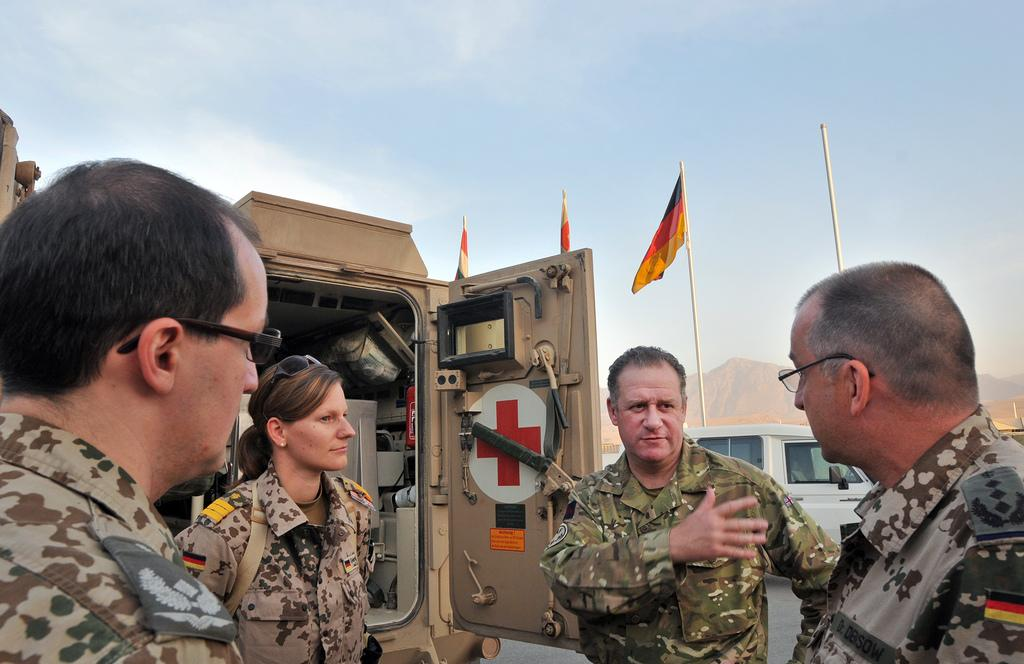How many military people are in the image? There are four military people in the image. What type of vehicle is present in the image? There is a hospital van with some equipment in the image. What can be seen in the sky in the image? The sky is visible in the image. What is the road condition in the image? There is a vehicle on the road in the image. What type of flags are in the image? There are flags in the image. What type of geographical feature is visible in the image? There is a mountain visible in the image. What type of camera is being used by the military people in the image? There is no camera visible in the image, and it is not mentioned that the military people are using one. What type of vacation destination is visible in the image? There is no vacation destination visible in the image; it features military personnel, a hospital van, and a mountain. 